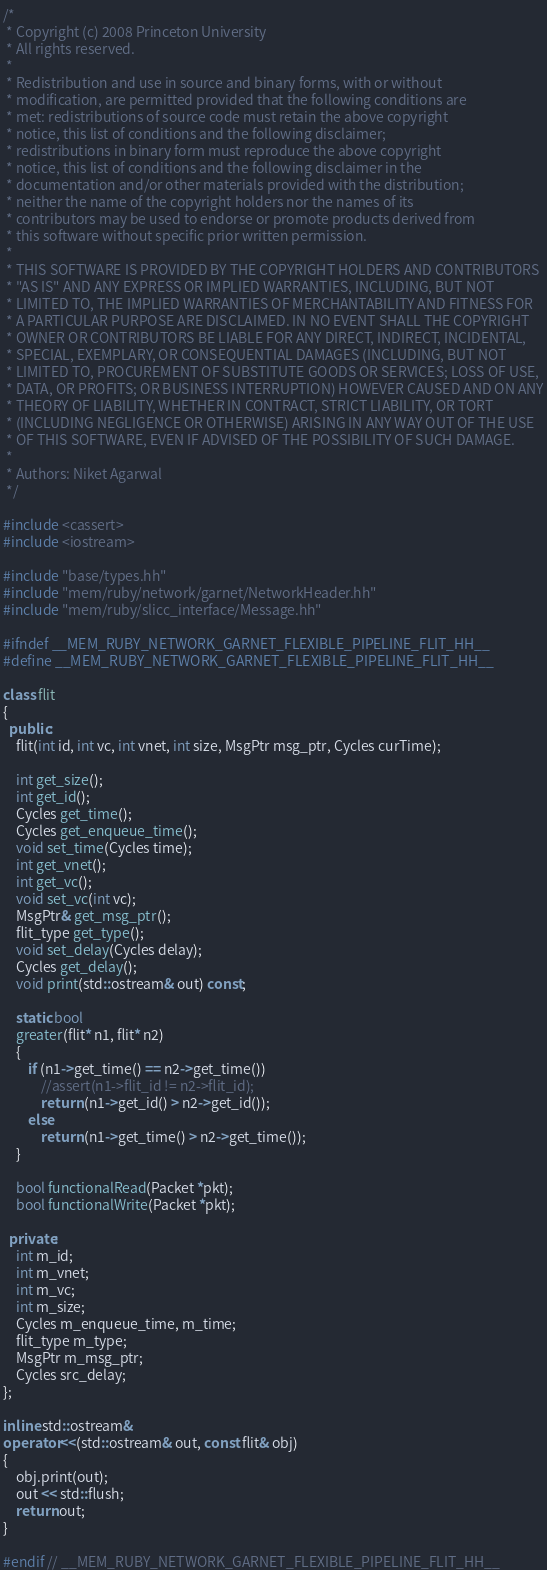<code> <loc_0><loc_0><loc_500><loc_500><_C++_>/*
 * Copyright (c) 2008 Princeton University
 * All rights reserved.
 *
 * Redistribution and use in source and binary forms, with or without
 * modification, are permitted provided that the following conditions are
 * met: redistributions of source code must retain the above copyright
 * notice, this list of conditions and the following disclaimer;
 * redistributions in binary form must reproduce the above copyright
 * notice, this list of conditions and the following disclaimer in the
 * documentation and/or other materials provided with the distribution;
 * neither the name of the copyright holders nor the names of its
 * contributors may be used to endorse or promote products derived from
 * this software without specific prior written permission.
 *
 * THIS SOFTWARE IS PROVIDED BY THE COPYRIGHT HOLDERS AND CONTRIBUTORS
 * "AS IS" AND ANY EXPRESS OR IMPLIED WARRANTIES, INCLUDING, BUT NOT
 * LIMITED TO, THE IMPLIED WARRANTIES OF MERCHANTABILITY AND FITNESS FOR
 * A PARTICULAR PURPOSE ARE DISCLAIMED. IN NO EVENT SHALL THE COPYRIGHT
 * OWNER OR CONTRIBUTORS BE LIABLE FOR ANY DIRECT, INDIRECT, INCIDENTAL,
 * SPECIAL, EXEMPLARY, OR CONSEQUENTIAL DAMAGES (INCLUDING, BUT NOT
 * LIMITED TO, PROCUREMENT OF SUBSTITUTE GOODS OR SERVICES; LOSS OF USE,
 * DATA, OR PROFITS; OR BUSINESS INTERRUPTION) HOWEVER CAUSED AND ON ANY
 * THEORY OF LIABILITY, WHETHER IN CONTRACT, STRICT LIABILITY, OR TORT
 * (INCLUDING NEGLIGENCE OR OTHERWISE) ARISING IN ANY WAY OUT OF THE USE
 * OF THIS SOFTWARE, EVEN IF ADVISED OF THE POSSIBILITY OF SUCH DAMAGE.
 *
 * Authors: Niket Agarwal
 */

#include <cassert>
#include <iostream>

#include "base/types.hh"
#include "mem/ruby/network/garnet/NetworkHeader.hh"
#include "mem/ruby/slicc_interface/Message.hh"

#ifndef __MEM_RUBY_NETWORK_GARNET_FLEXIBLE_PIPELINE_FLIT_HH__
#define __MEM_RUBY_NETWORK_GARNET_FLEXIBLE_PIPELINE_FLIT_HH__

class flit
{
  public:
    flit(int id, int vc, int vnet, int size, MsgPtr msg_ptr, Cycles curTime);

    int get_size();
    int get_id();
    Cycles get_time();
    Cycles get_enqueue_time();
    void set_time(Cycles time);
    int get_vnet();
    int get_vc();
    void set_vc(int vc);
    MsgPtr& get_msg_ptr();
    flit_type get_type();
    void set_delay(Cycles delay);
    Cycles get_delay();
    void print(std::ostream& out) const;

    static bool
    greater(flit* n1, flit* n2)
    {
        if (n1->get_time() == n2->get_time())
            //assert(n1->flit_id != n2->flit_id);
            return (n1->get_id() > n2->get_id());
        else
            return (n1->get_time() > n2->get_time());
    }

    bool functionalRead(Packet *pkt);
    bool functionalWrite(Packet *pkt);

  private:
    int m_id;
    int m_vnet;
    int m_vc;
    int m_size;
    Cycles m_enqueue_time, m_time;
    flit_type m_type;
    MsgPtr m_msg_ptr;
    Cycles src_delay;
};

inline std::ostream&
operator<<(std::ostream& out, const flit& obj)
{
    obj.print(out);
    out << std::flush;
    return out;
}

#endif // __MEM_RUBY_NETWORK_GARNET_FLEXIBLE_PIPELINE_FLIT_HH__
</code> 